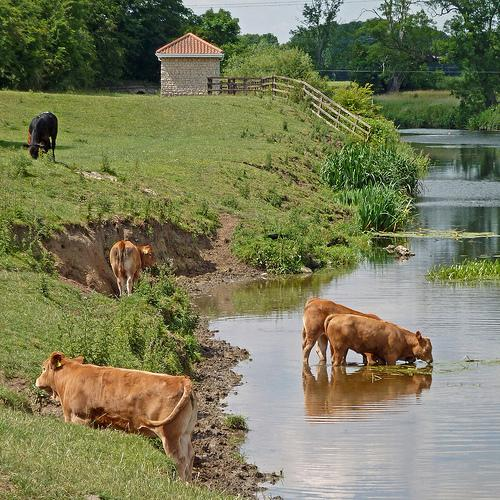Question: what is at the edge of the water in the front?
Choices:
A. Sand.
B. Rocks.
C. Mud.
D. Grass.
Answer with the letter. Answer: C Question: what animals are pictured here?
Choices:
A. Buffalo.
B. Cows.
C. Goats.
D. Pigs.
Answer with the letter. Answer: B 